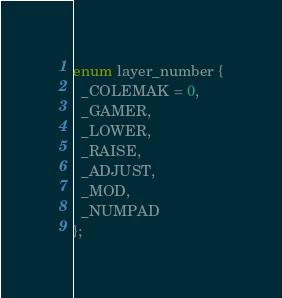<code> <loc_0><loc_0><loc_500><loc_500><_C_>enum layer_number {
  _COLEMAK = 0,
  _GAMER,
  _LOWER,
  _RAISE,
  _ADJUST,
  _MOD,
  _NUMPAD
};
</code> 